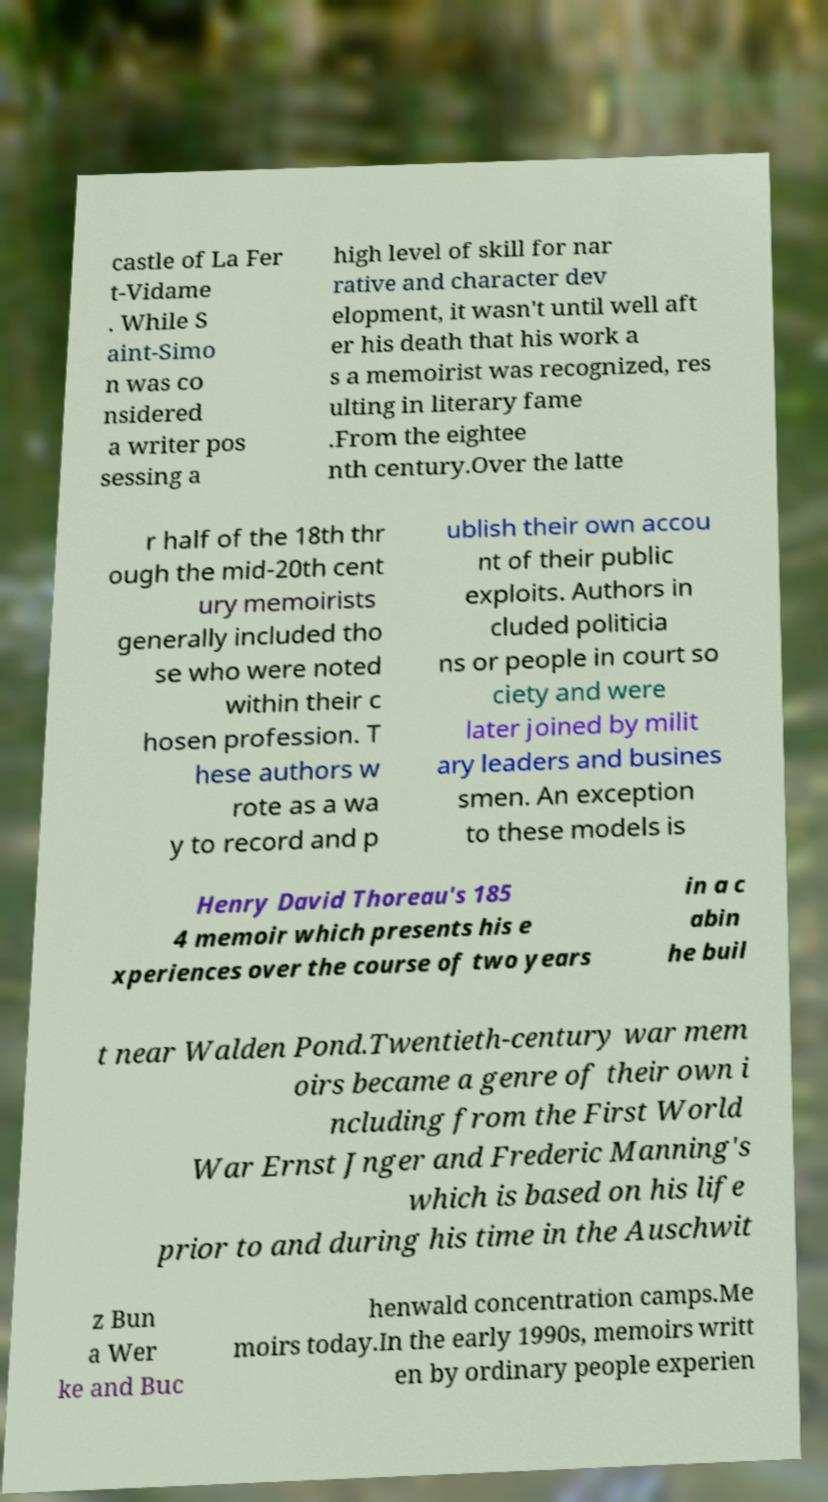Please read and relay the text visible in this image. What does it say? castle of La Fer t-Vidame . While S aint-Simo n was co nsidered a writer pos sessing a high level of skill for nar rative and character dev elopment, it wasn't until well aft er his death that his work a s a memoirist was recognized, res ulting in literary fame .From the eightee nth century.Over the latte r half of the 18th thr ough the mid-20th cent ury memoirists generally included tho se who were noted within their c hosen profession. T hese authors w rote as a wa y to record and p ublish their own accou nt of their public exploits. Authors in cluded politicia ns or people in court so ciety and were later joined by milit ary leaders and busines smen. An exception to these models is Henry David Thoreau's 185 4 memoir which presents his e xperiences over the course of two years in a c abin he buil t near Walden Pond.Twentieth-century war mem oirs became a genre of their own i ncluding from the First World War Ernst Jnger and Frederic Manning's which is based on his life prior to and during his time in the Auschwit z Bun a Wer ke and Buc henwald concentration camps.Me moirs today.In the early 1990s, memoirs writt en by ordinary people experien 